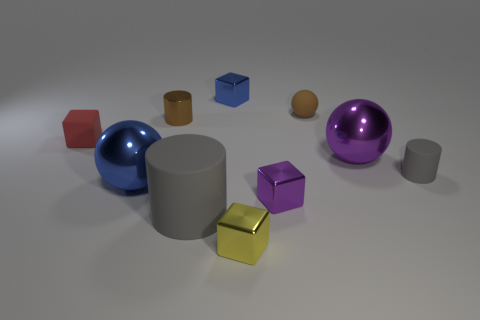How many tiny objects are matte objects or blue cubes?
Keep it short and to the point. 4. Are there any large blue metallic things of the same shape as the small red rubber object?
Provide a short and direct response. No. Is the small brown metallic object the same shape as the brown matte thing?
Your answer should be very brief. No. There is a cylinder that is behind the gray rubber cylinder on the right side of the small yellow metallic cube; what color is it?
Provide a short and direct response. Brown. There is a rubber block that is the same size as the brown sphere; what color is it?
Your answer should be very brief. Red. What number of matte objects are blue objects or brown cylinders?
Give a very brief answer. 0. There is a brown object that is left of the small blue cube; how many small yellow shiny blocks are behind it?
Offer a very short reply. 0. What is the size of the shiny object that is the same color as the rubber ball?
Keep it short and to the point. Small. How many things are either red matte blocks or small objects to the right of the purple metallic sphere?
Your response must be concise. 2. Is there a blue cylinder that has the same material as the small blue object?
Provide a succinct answer. No. 